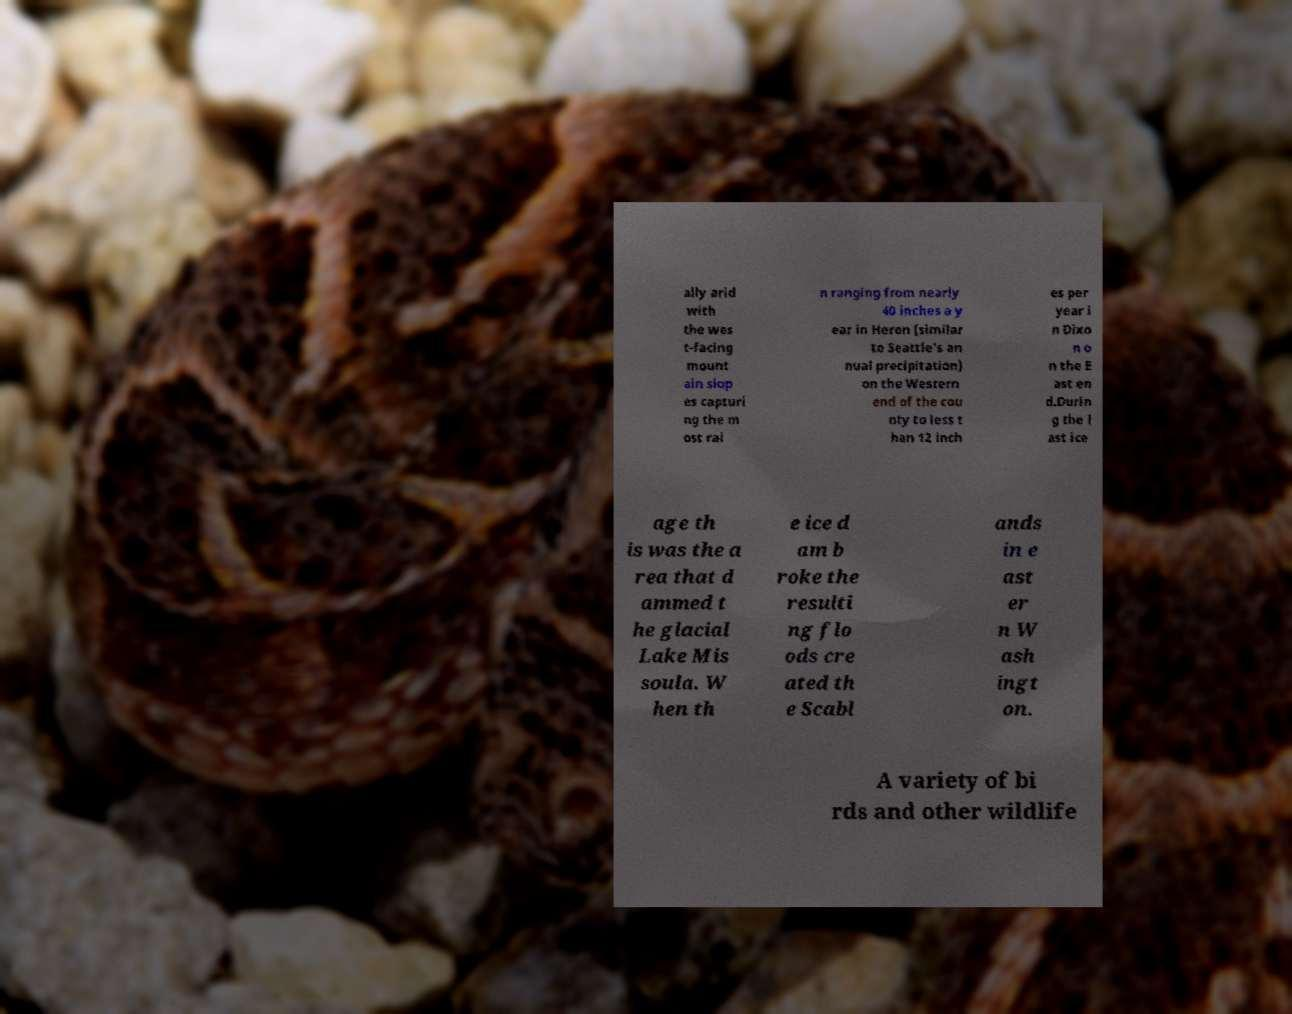Please identify and transcribe the text found in this image. ally arid with the wes t-facing mount ain slop es capturi ng the m ost rai n ranging from nearly 40 inches a y ear in Heron (similar to Seattle's an nual precipitation) on the Western end of the cou nty to less t han 12 inch es per year i n Dixo n o n the E ast en d.Durin g the l ast ice age th is was the a rea that d ammed t he glacial Lake Mis soula. W hen th e ice d am b roke the resulti ng flo ods cre ated th e Scabl ands in e ast er n W ash ingt on. A variety of bi rds and other wildlife 